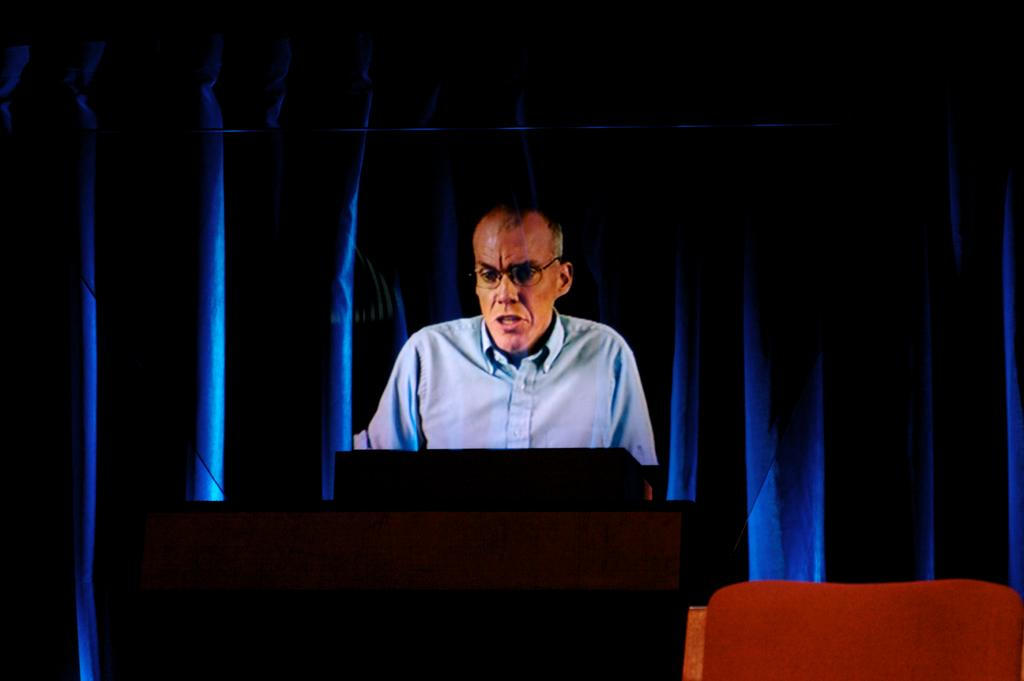How many people are in the image? There is one person in the image. What is on the table in the image? There is an object on a table in the image. What can be seen in the background of the image? There is a curtain in the background of the image. Is the baby in the image using a credit card to spy on the person? There is no baby or credit card present in the image, and the person is not being spied on. 